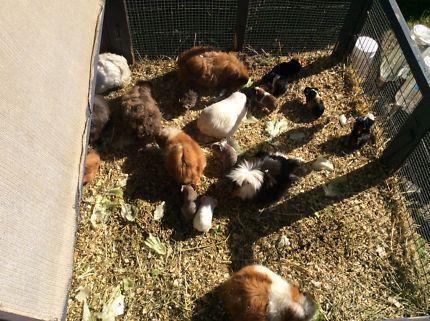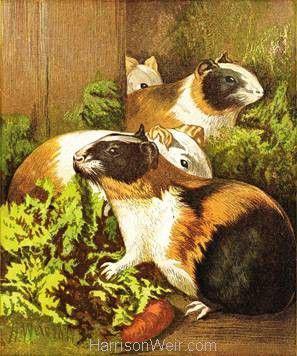The first image is the image on the left, the second image is the image on the right. For the images shown, is this caption "There are exactly six guinea pigs in the left image and some of them are eating." true? Answer yes or no. No. The first image is the image on the left, the second image is the image on the right. Analyze the images presented: Is the assertion "Left image shows tan and white hamsters with green leafy items to eat in front of them." valid? Answer yes or no. No. 